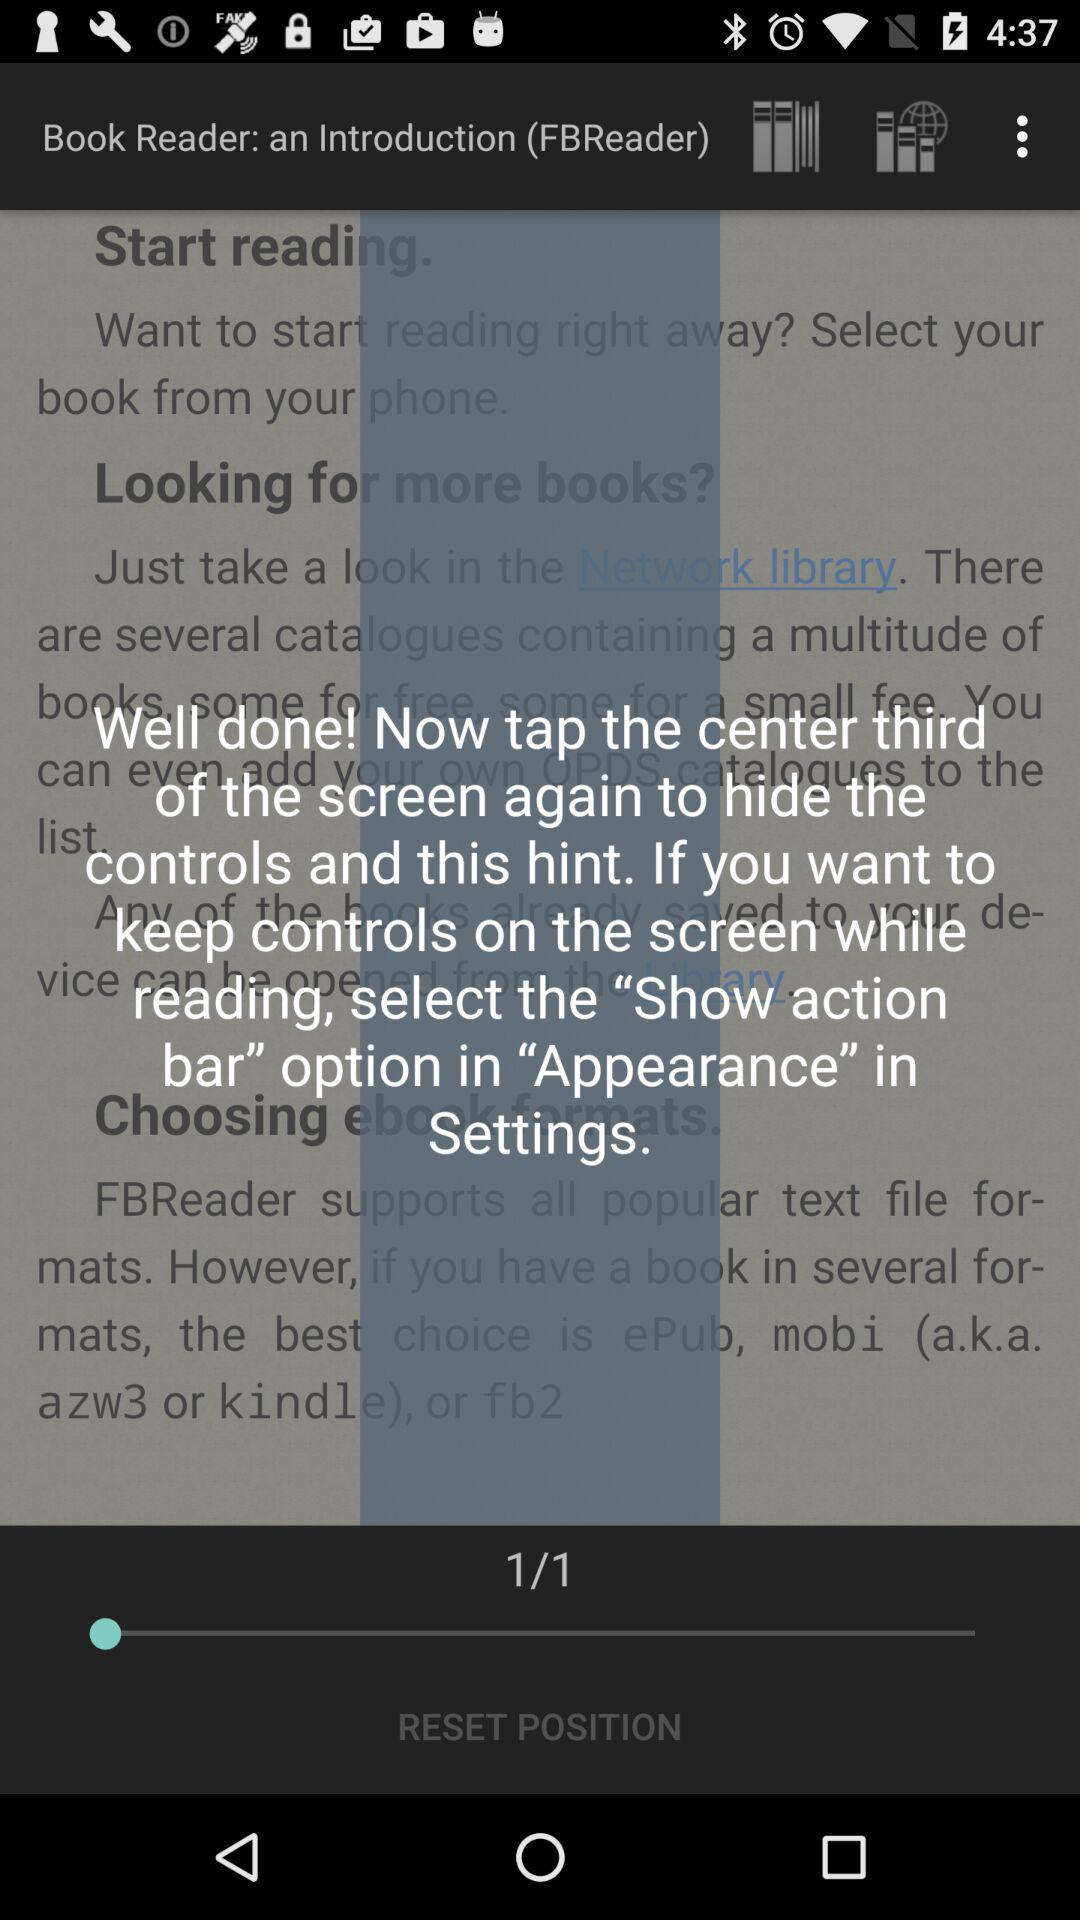At which page am I? You are at the 1 page. 